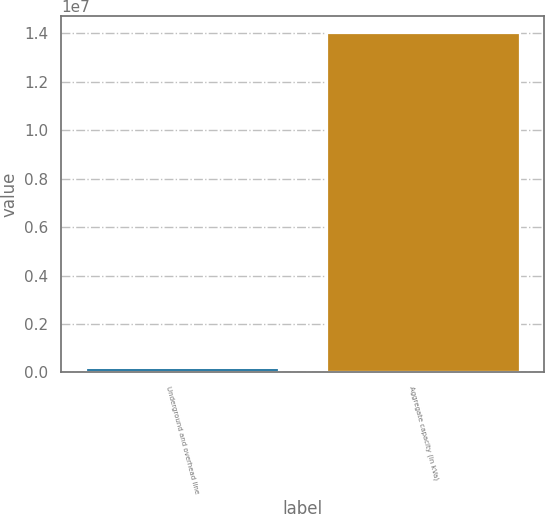Convert chart. <chart><loc_0><loc_0><loc_500><loc_500><bar_chart><fcel>Underground and overhead line<fcel>Aggregate capacity (in kVa)<nl><fcel>170383<fcel>1.39962e+07<nl></chart> 